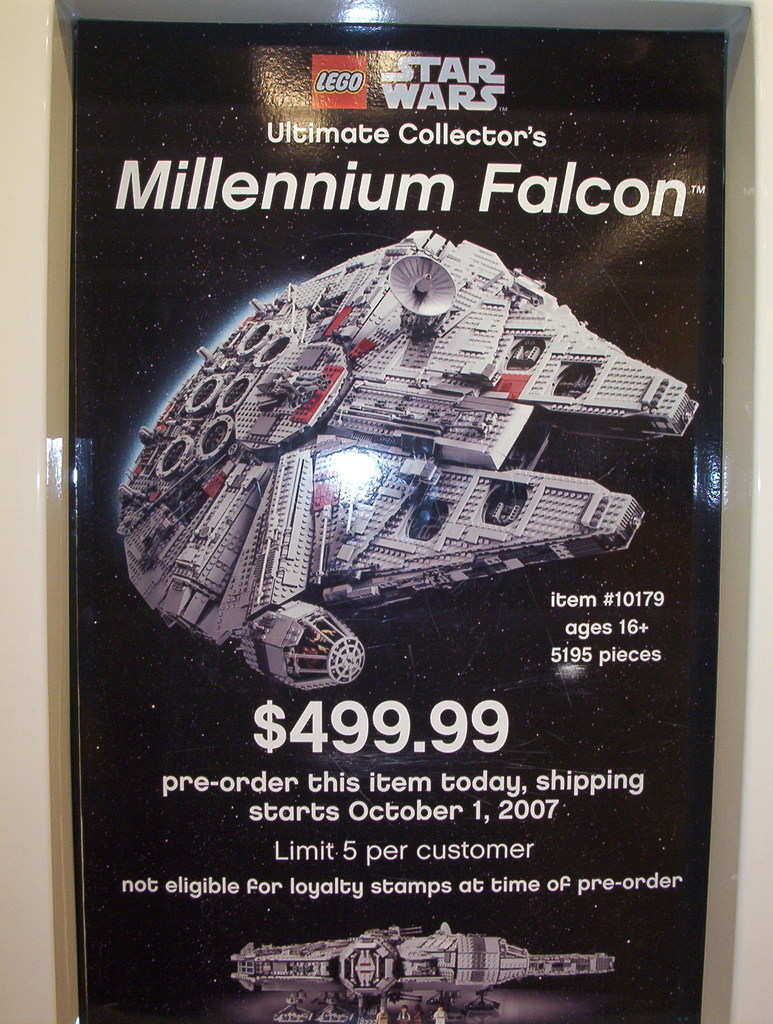Provide a one-sentence caption for the provided image. The advertisement showcases the Lego Star Wars Ultimate Collector's Millennium Falcon, set number #10179, targeted at ages 16+ with 5195 pieces, priced at $499.99, available for pre-order with shipping starting October 1, 2007, and a limit of 5 per customer. 